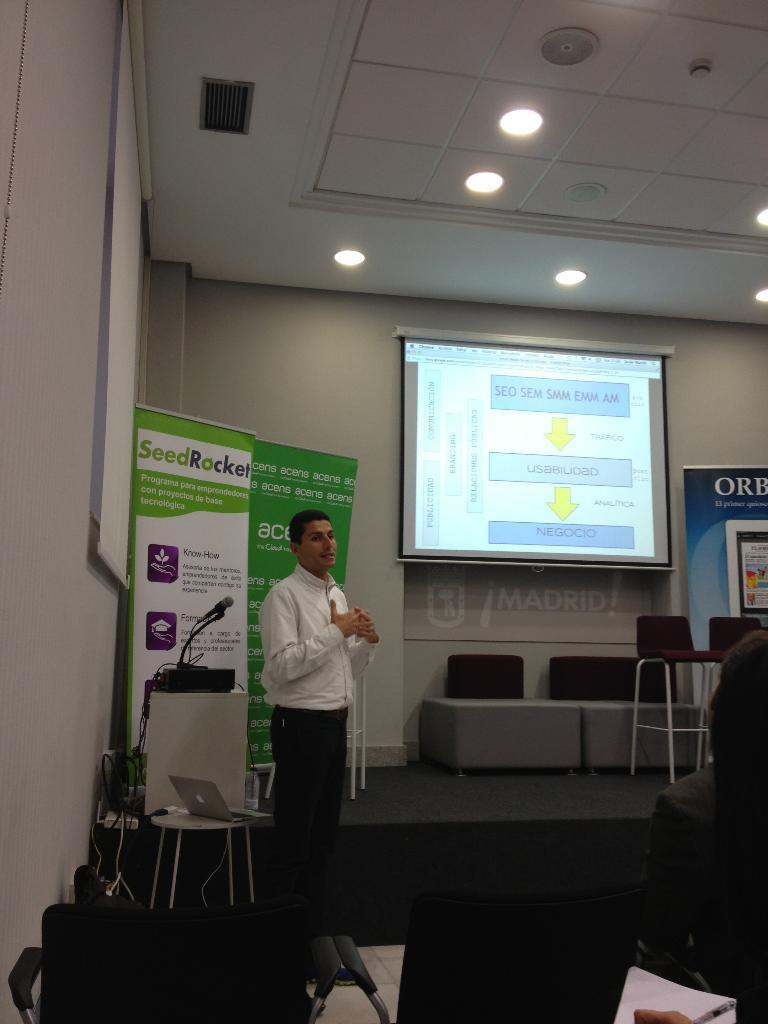What is the color of the wall in the image? The wall in the image is white. What can be seen hanging on the wall? There is a banner in the image. What is the main object in the middle of the image? There is a screen in the image. What type of furniture is present in the image? There is a sofa in the image. Who is present in the image? There is a man standing in the image. What type of worm can be seen crawling on the man's shoulder in the image? There is no worm present in the image; the man is standing without any visible creatures on his shoulder. 